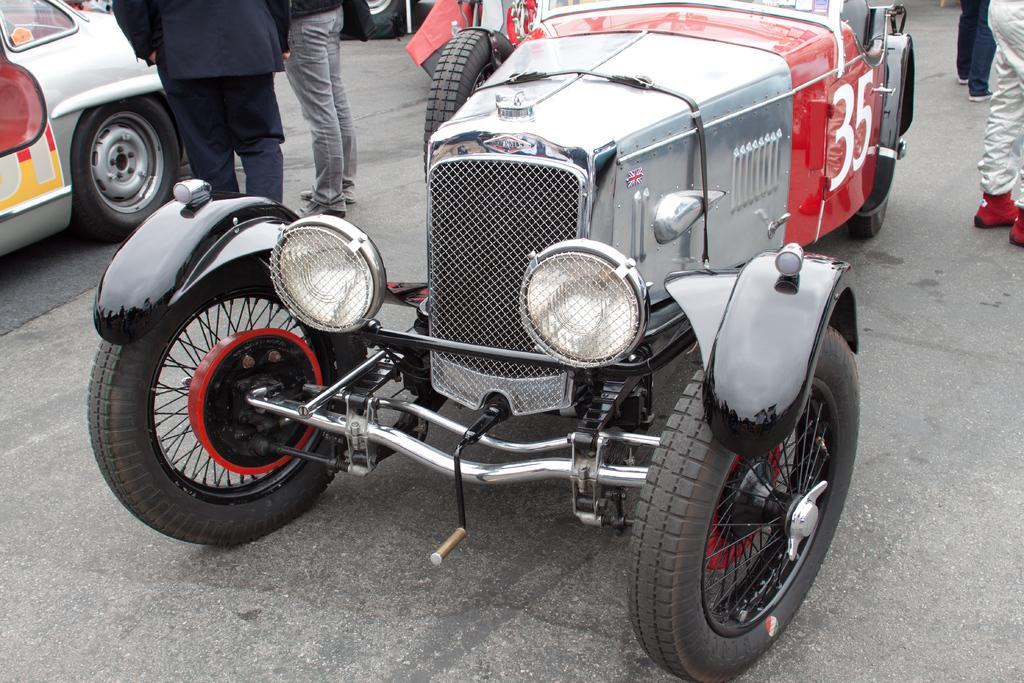What types of objects can be seen in the image? There are vehicles in the image. Are there any people present in the image? Yes, there are people standing on the road in the image. Who is the creator of the vehicles in the image? The image does not provide information about the creators of the vehicles, so it cannot be determined from the image. What type of bag is being carried by the porter in the image? There is no porter or bag present in the image. 